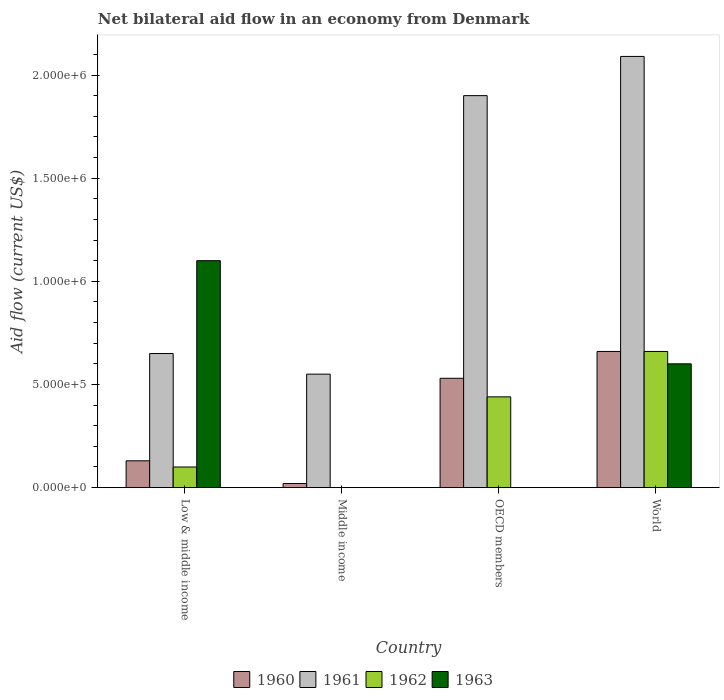How many groups of bars are there?
Give a very brief answer. 4. Across all countries, what is the maximum net bilateral aid flow in 1963?
Give a very brief answer. 1.10e+06. Across all countries, what is the minimum net bilateral aid flow in 1961?
Provide a succinct answer. 5.50e+05. In which country was the net bilateral aid flow in 1961 maximum?
Your answer should be compact. World. What is the total net bilateral aid flow in 1962 in the graph?
Ensure brevity in your answer.  1.20e+06. What is the difference between the net bilateral aid flow in 1961 in Low & middle income and that in Middle income?
Provide a short and direct response. 1.00e+05. What is the difference between the net bilateral aid flow in 1963 in Low & middle income and the net bilateral aid flow in 1962 in Middle income?
Offer a very short reply. 1.10e+06. What is the average net bilateral aid flow in 1963 per country?
Ensure brevity in your answer.  4.25e+05. What is the difference between the net bilateral aid flow of/in 1960 and net bilateral aid flow of/in 1963 in Low & middle income?
Offer a very short reply. -9.70e+05. In how many countries, is the net bilateral aid flow in 1960 greater than 1700000 US$?
Ensure brevity in your answer.  0. What is the ratio of the net bilateral aid flow in 1960 in Low & middle income to that in Middle income?
Ensure brevity in your answer.  6.5. What is the difference between the highest and the second highest net bilateral aid flow in 1961?
Provide a succinct answer. 1.44e+06. What is the difference between the highest and the lowest net bilateral aid flow in 1960?
Make the answer very short. 6.40e+05. In how many countries, is the net bilateral aid flow in 1960 greater than the average net bilateral aid flow in 1960 taken over all countries?
Provide a succinct answer. 2. Is the sum of the net bilateral aid flow in 1960 in Middle income and World greater than the maximum net bilateral aid flow in 1961 across all countries?
Ensure brevity in your answer.  No. Is it the case that in every country, the sum of the net bilateral aid flow in 1961 and net bilateral aid flow in 1960 is greater than the sum of net bilateral aid flow in 1963 and net bilateral aid flow in 1962?
Provide a short and direct response. No. How many countries are there in the graph?
Offer a very short reply. 4. What is the difference between two consecutive major ticks on the Y-axis?
Your answer should be compact. 5.00e+05. Does the graph contain any zero values?
Give a very brief answer. Yes. Where does the legend appear in the graph?
Provide a short and direct response. Bottom center. How many legend labels are there?
Offer a very short reply. 4. How are the legend labels stacked?
Offer a very short reply. Horizontal. What is the title of the graph?
Offer a terse response. Net bilateral aid flow in an economy from Denmark. What is the Aid flow (current US$) in 1961 in Low & middle income?
Make the answer very short. 6.50e+05. What is the Aid flow (current US$) of 1963 in Low & middle income?
Your answer should be very brief. 1.10e+06. What is the Aid flow (current US$) in 1961 in Middle income?
Keep it short and to the point. 5.50e+05. What is the Aid flow (current US$) of 1962 in Middle income?
Your answer should be compact. 0. What is the Aid flow (current US$) in 1960 in OECD members?
Make the answer very short. 5.30e+05. What is the Aid flow (current US$) of 1961 in OECD members?
Give a very brief answer. 1.90e+06. What is the Aid flow (current US$) in 1962 in OECD members?
Your answer should be very brief. 4.40e+05. What is the Aid flow (current US$) in 1961 in World?
Your answer should be very brief. 2.09e+06. Across all countries, what is the maximum Aid flow (current US$) of 1960?
Ensure brevity in your answer.  6.60e+05. Across all countries, what is the maximum Aid flow (current US$) in 1961?
Your answer should be compact. 2.09e+06. Across all countries, what is the maximum Aid flow (current US$) in 1962?
Your response must be concise. 6.60e+05. Across all countries, what is the maximum Aid flow (current US$) in 1963?
Your response must be concise. 1.10e+06. Across all countries, what is the minimum Aid flow (current US$) in 1960?
Make the answer very short. 2.00e+04. Across all countries, what is the minimum Aid flow (current US$) in 1961?
Provide a short and direct response. 5.50e+05. What is the total Aid flow (current US$) in 1960 in the graph?
Your answer should be very brief. 1.34e+06. What is the total Aid flow (current US$) of 1961 in the graph?
Keep it short and to the point. 5.19e+06. What is the total Aid flow (current US$) of 1962 in the graph?
Offer a terse response. 1.20e+06. What is the total Aid flow (current US$) of 1963 in the graph?
Make the answer very short. 1.70e+06. What is the difference between the Aid flow (current US$) of 1960 in Low & middle income and that in OECD members?
Ensure brevity in your answer.  -4.00e+05. What is the difference between the Aid flow (current US$) in 1961 in Low & middle income and that in OECD members?
Offer a terse response. -1.25e+06. What is the difference between the Aid flow (current US$) in 1962 in Low & middle income and that in OECD members?
Your response must be concise. -3.40e+05. What is the difference between the Aid flow (current US$) in 1960 in Low & middle income and that in World?
Provide a succinct answer. -5.30e+05. What is the difference between the Aid flow (current US$) in 1961 in Low & middle income and that in World?
Provide a short and direct response. -1.44e+06. What is the difference between the Aid flow (current US$) of 1962 in Low & middle income and that in World?
Your answer should be compact. -5.60e+05. What is the difference between the Aid flow (current US$) of 1963 in Low & middle income and that in World?
Offer a very short reply. 5.00e+05. What is the difference between the Aid flow (current US$) of 1960 in Middle income and that in OECD members?
Provide a short and direct response. -5.10e+05. What is the difference between the Aid flow (current US$) of 1961 in Middle income and that in OECD members?
Give a very brief answer. -1.35e+06. What is the difference between the Aid flow (current US$) in 1960 in Middle income and that in World?
Ensure brevity in your answer.  -6.40e+05. What is the difference between the Aid flow (current US$) in 1961 in Middle income and that in World?
Your answer should be very brief. -1.54e+06. What is the difference between the Aid flow (current US$) in 1960 in OECD members and that in World?
Your answer should be compact. -1.30e+05. What is the difference between the Aid flow (current US$) in 1961 in OECD members and that in World?
Ensure brevity in your answer.  -1.90e+05. What is the difference between the Aid flow (current US$) of 1960 in Low & middle income and the Aid flow (current US$) of 1961 in Middle income?
Ensure brevity in your answer.  -4.20e+05. What is the difference between the Aid flow (current US$) in 1960 in Low & middle income and the Aid flow (current US$) in 1961 in OECD members?
Ensure brevity in your answer.  -1.77e+06. What is the difference between the Aid flow (current US$) in 1960 in Low & middle income and the Aid flow (current US$) in 1962 in OECD members?
Offer a very short reply. -3.10e+05. What is the difference between the Aid flow (current US$) in 1960 in Low & middle income and the Aid flow (current US$) in 1961 in World?
Provide a succinct answer. -1.96e+06. What is the difference between the Aid flow (current US$) of 1960 in Low & middle income and the Aid flow (current US$) of 1962 in World?
Offer a terse response. -5.30e+05. What is the difference between the Aid flow (current US$) of 1960 in Low & middle income and the Aid flow (current US$) of 1963 in World?
Offer a very short reply. -4.70e+05. What is the difference between the Aid flow (current US$) in 1961 in Low & middle income and the Aid flow (current US$) in 1962 in World?
Give a very brief answer. -10000. What is the difference between the Aid flow (current US$) in 1961 in Low & middle income and the Aid flow (current US$) in 1963 in World?
Offer a terse response. 5.00e+04. What is the difference between the Aid flow (current US$) of 1962 in Low & middle income and the Aid flow (current US$) of 1963 in World?
Provide a short and direct response. -5.00e+05. What is the difference between the Aid flow (current US$) in 1960 in Middle income and the Aid flow (current US$) in 1961 in OECD members?
Make the answer very short. -1.88e+06. What is the difference between the Aid flow (current US$) in 1960 in Middle income and the Aid flow (current US$) in 1962 in OECD members?
Offer a very short reply. -4.20e+05. What is the difference between the Aid flow (current US$) in 1960 in Middle income and the Aid flow (current US$) in 1961 in World?
Keep it short and to the point. -2.07e+06. What is the difference between the Aid flow (current US$) in 1960 in Middle income and the Aid flow (current US$) in 1962 in World?
Your answer should be compact. -6.40e+05. What is the difference between the Aid flow (current US$) in 1960 in Middle income and the Aid flow (current US$) in 1963 in World?
Provide a succinct answer. -5.80e+05. What is the difference between the Aid flow (current US$) in 1961 in Middle income and the Aid flow (current US$) in 1962 in World?
Give a very brief answer. -1.10e+05. What is the difference between the Aid flow (current US$) in 1960 in OECD members and the Aid flow (current US$) in 1961 in World?
Offer a terse response. -1.56e+06. What is the difference between the Aid flow (current US$) in 1960 in OECD members and the Aid flow (current US$) in 1963 in World?
Provide a short and direct response. -7.00e+04. What is the difference between the Aid flow (current US$) in 1961 in OECD members and the Aid flow (current US$) in 1962 in World?
Provide a succinct answer. 1.24e+06. What is the difference between the Aid flow (current US$) of 1961 in OECD members and the Aid flow (current US$) of 1963 in World?
Give a very brief answer. 1.30e+06. What is the difference between the Aid flow (current US$) of 1962 in OECD members and the Aid flow (current US$) of 1963 in World?
Your response must be concise. -1.60e+05. What is the average Aid flow (current US$) of 1960 per country?
Provide a short and direct response. 3.35e+05. What is the average Aid flow (current US$) in 1961 per country?
Give a very brief answer. 1.30e+06. What is the average Aid flow (current US$) of 1962 per country?
Provide a short and direct response. 3.00e+05. What is the average Aid flow (current US$) of 1963 per country?
Provide a short and direct response. 4.25e+05. What is the difference between the Aid flow (current US$) in 1960 and Aid flow (current US$) in 1961 in Low & middle income?
Make the answer very short. -5.20e+05. What is the difference between the Aid flow (current US$) of 1960 and Aid flow (current US$) of 1963 in Low & middle income?
Give a very brief answer. -9.70e+05. What is the difference between the Aid flow (current US$) in 1961 and Aid flow (current US$) in 1963 in Low & middle income?
Ensure brevity in your answer.  -4.50e+05. What is the difference between the Aid flow (current US$) of 1962 and Aid flow (current US$) of 1963 in Low & middle income?
Offer a terse response. -1.00e+06. What is the difference between the Aid flow (current US$) of 1960 and Aid flow (current US$) of 1961 in Middle income?
Provide a short and direct response. -5.30e+05. What is the difference between the Aid flow (current US$) in 1960 and Aid flow (current US$) in 1961 in OECD members?
Offer a terse response. -1.37e+06. What is the difference between the Aid flow (current US$) of 1960 and Aid flow (current US$) of 1962 in OECD members?
Keep it short and to the point. 9.00e+04. What is the difference between the Aid flow (current US$) in 1961 and Aid flow (current US$) in 1962 in OECD members?
Provide a short and direct response. 1.46e+06. What is the difference between the Aid flow (current US$) of 1960 and Aid flow (current US$) of 1961 in World?
Provide a short and direct response. -1.43e+06. What is the difference between the Aid flow (current US$) of 1960 and Aid flow (current US$) of 1962 in World?
Provide a short and direct response. 0. What is the difference between the Aid flow (current US$) in 1961 and Aid flow (current US$) in 1962 in World?
Ensure brevity in your answer.  1.43e+06. What is the difference between the Aid flow (current US$) in 1961 and Aid flow (current US$) in 1963 in World?
Your answer should be very brief. 1.49e+06. What is the difference between the Aid flow (current US$) in 1962 and Aid flow (current US$) in 1963 in World?
Your response must be concise. 6.00e+04. What is the ratio of the Aid flow (current US$) in 1960 in Low & middle income to that in Middle income?
Your answer should be compact. 6.5. What is the ratio of the Aid flow (current US$) in 1961 in Low & middle income to that in Middle income?
Give a very brief answer. 1.18. What is the ratio of the Aid flow (current US$) of 1960 in Low & middle income to that in OECD members?
Ensure brevity in your answer.  0.25. What is the ratio of the Aid flow (current US$) of 1961 in Low & middle income to that in OECD members?
Make the answer very short. 0.34. What is the ratio of the Aid flow (current US$) of 1962 in Low & middle income to that in OECD members?
Offer a terse response. 0.23. What is the ratio of the Aid flow (current US$) of 1960 in Low & middle income to that in World?
Offer a terse response. 0.2. What is the ratio of the Aid flow (current US$) of 1961 in Low & middle income to that in World?
Provide a succinct answer. 0.31. What is the ratio of the Aid flow (current US$) of 1962 in Low & middle income to that in World?
Ensure brevity in your answer.  0.15. What is the ratio of the Aid flow (current US$) of 1963 in Low & middle income to that in World?
Keep it short and to the point. 1.83. What is the ratio of the Aid flow (current US$) in 1960 in Middle income to that in OECD members?
Offer a very short reply. 0.04. What is the ratio of the Aid flow (current US$) of 1961 in Middle income to that in OECD members?
Ensure brevity in your answer.  0.29. What is the ratio of the Aid flow (current US$) of 1960 in Middle income to that in World?
Your answer should be compact. 0.03. What is the ratio of the Aid flow (current US$) in 1961 in Middle income to that in World?
Make the answer very short. 0.26. What is the ratio of the Aid flow (current US$) in 1960 in OECD members to that in World?
Your answer should be compact. 0.8. What is the ratio of the Aid flow (current US$) of 1961 in OECD members to that in World?
Your answer should be very brief. 0.91. What is the difference between the highest and the second highest Aid flow (current US$) in 1960?
Offer a very short reply. 1.30e+05. What is the difference between the highest and the lowest Aid flow (current US$) in 1960?
Offer a very short reply. 6.40e+05. What is the difference between the highest and the lowest Aid flow (current US$) in 1961?
Offer a terse response. 1.54e+06. What is the difference between the highest and the lowest Aid flow (current US$) of 1962?
Keep it short and to the point. 6.60e+05. What is the difference between the highest and the lowest Aid flow (current US$) in 1963?
Make the answer very short. 1.10e+06. 